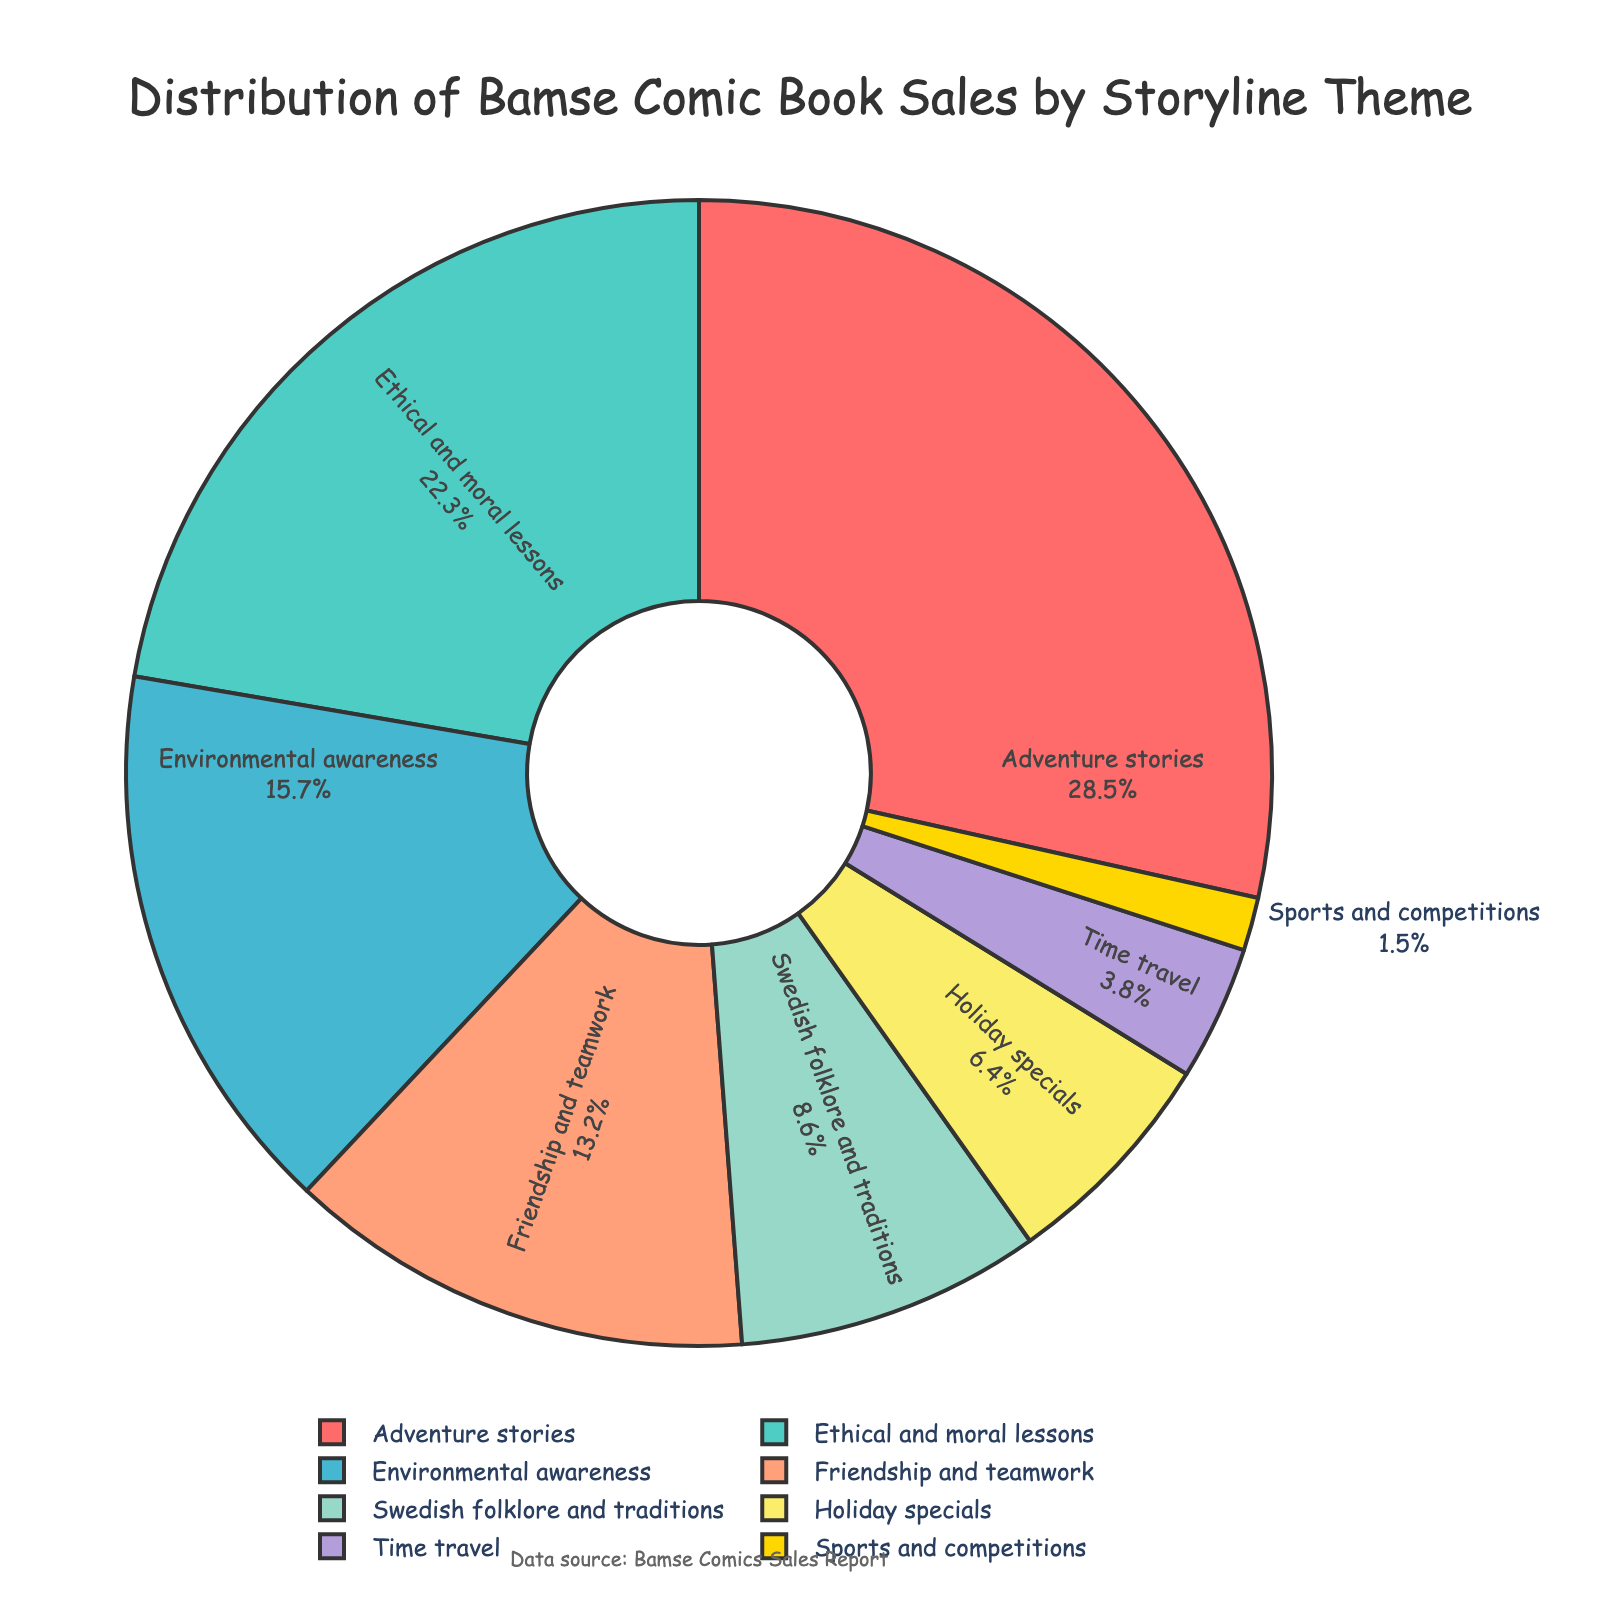Which theme has the highest percentage in the pie chart? Look at the segment with the largest area. It is labeled as "Adventure stories" with 28.5%.
Answer: Adventure stories Which theme occupies the smallest portion of the chart? Check for the smallest visual segment in the pie chart. It's "Sports and competitions" with 1.5%.
Answer: Sports and competitions What is the combined percentage of the "Environmental awareness" and "Ethical and moral lessons" themes? Add the percentages of these two themes: 15.7% (Environmental awareness) + 22.3% (Ethical and moral lessons) = 38%.
Answer: 38% How does the percentage of "Friendship and teamwork" compare to "Swedish folklore and traditions"? Compare their values: 13.2% (Friendship and teamwork) is greater than 8.6% (Swedish folklore and traditions).
Answer: Friendship and teamwork What fraction of the total percentage is represented by "Holiday specials" compared to "Time travel"? Compute the ratio: 6.4% (Holiday specials) / 3.8% (Time travel) ≈ 1.68. Thus, "Holiday specials" is about 1.68 times "Time travel".
Answer: 1.68 How much more in percentage is "Adventure stories" compared to the average percentage across all themes? First, calculate the average percentage: (28.5 + 22.3 + 15.7 + 13.2 + 8.6 + 6.4 + 3.8 + 1.5) / 8 = 12.5%. Then, find the difference: 28.5% - 12.5% = 16%.
Answer: 16% Does the sum of the percentages of "Holiday specials" and "Swedish folklore and traditions" exceed "Ethical and moral lessons"? Add "Holiday specials" and "Swedish folklore and traditions": 6.4% + 8.6% = 15%. Compare this with 22.3% (Ethical and moral lessons). 15% is less than 22.3%.
Answer: No Which themes together make up more than half of the pie chart? Sum themes from the highest until the total exceeds 50%: 28.5% (Adventure stories) + 22.3% (Ethical and moral lessons) = 50.8%, which is slightly above half.
Answer: Adventure stories and Ethical and moral lessons 